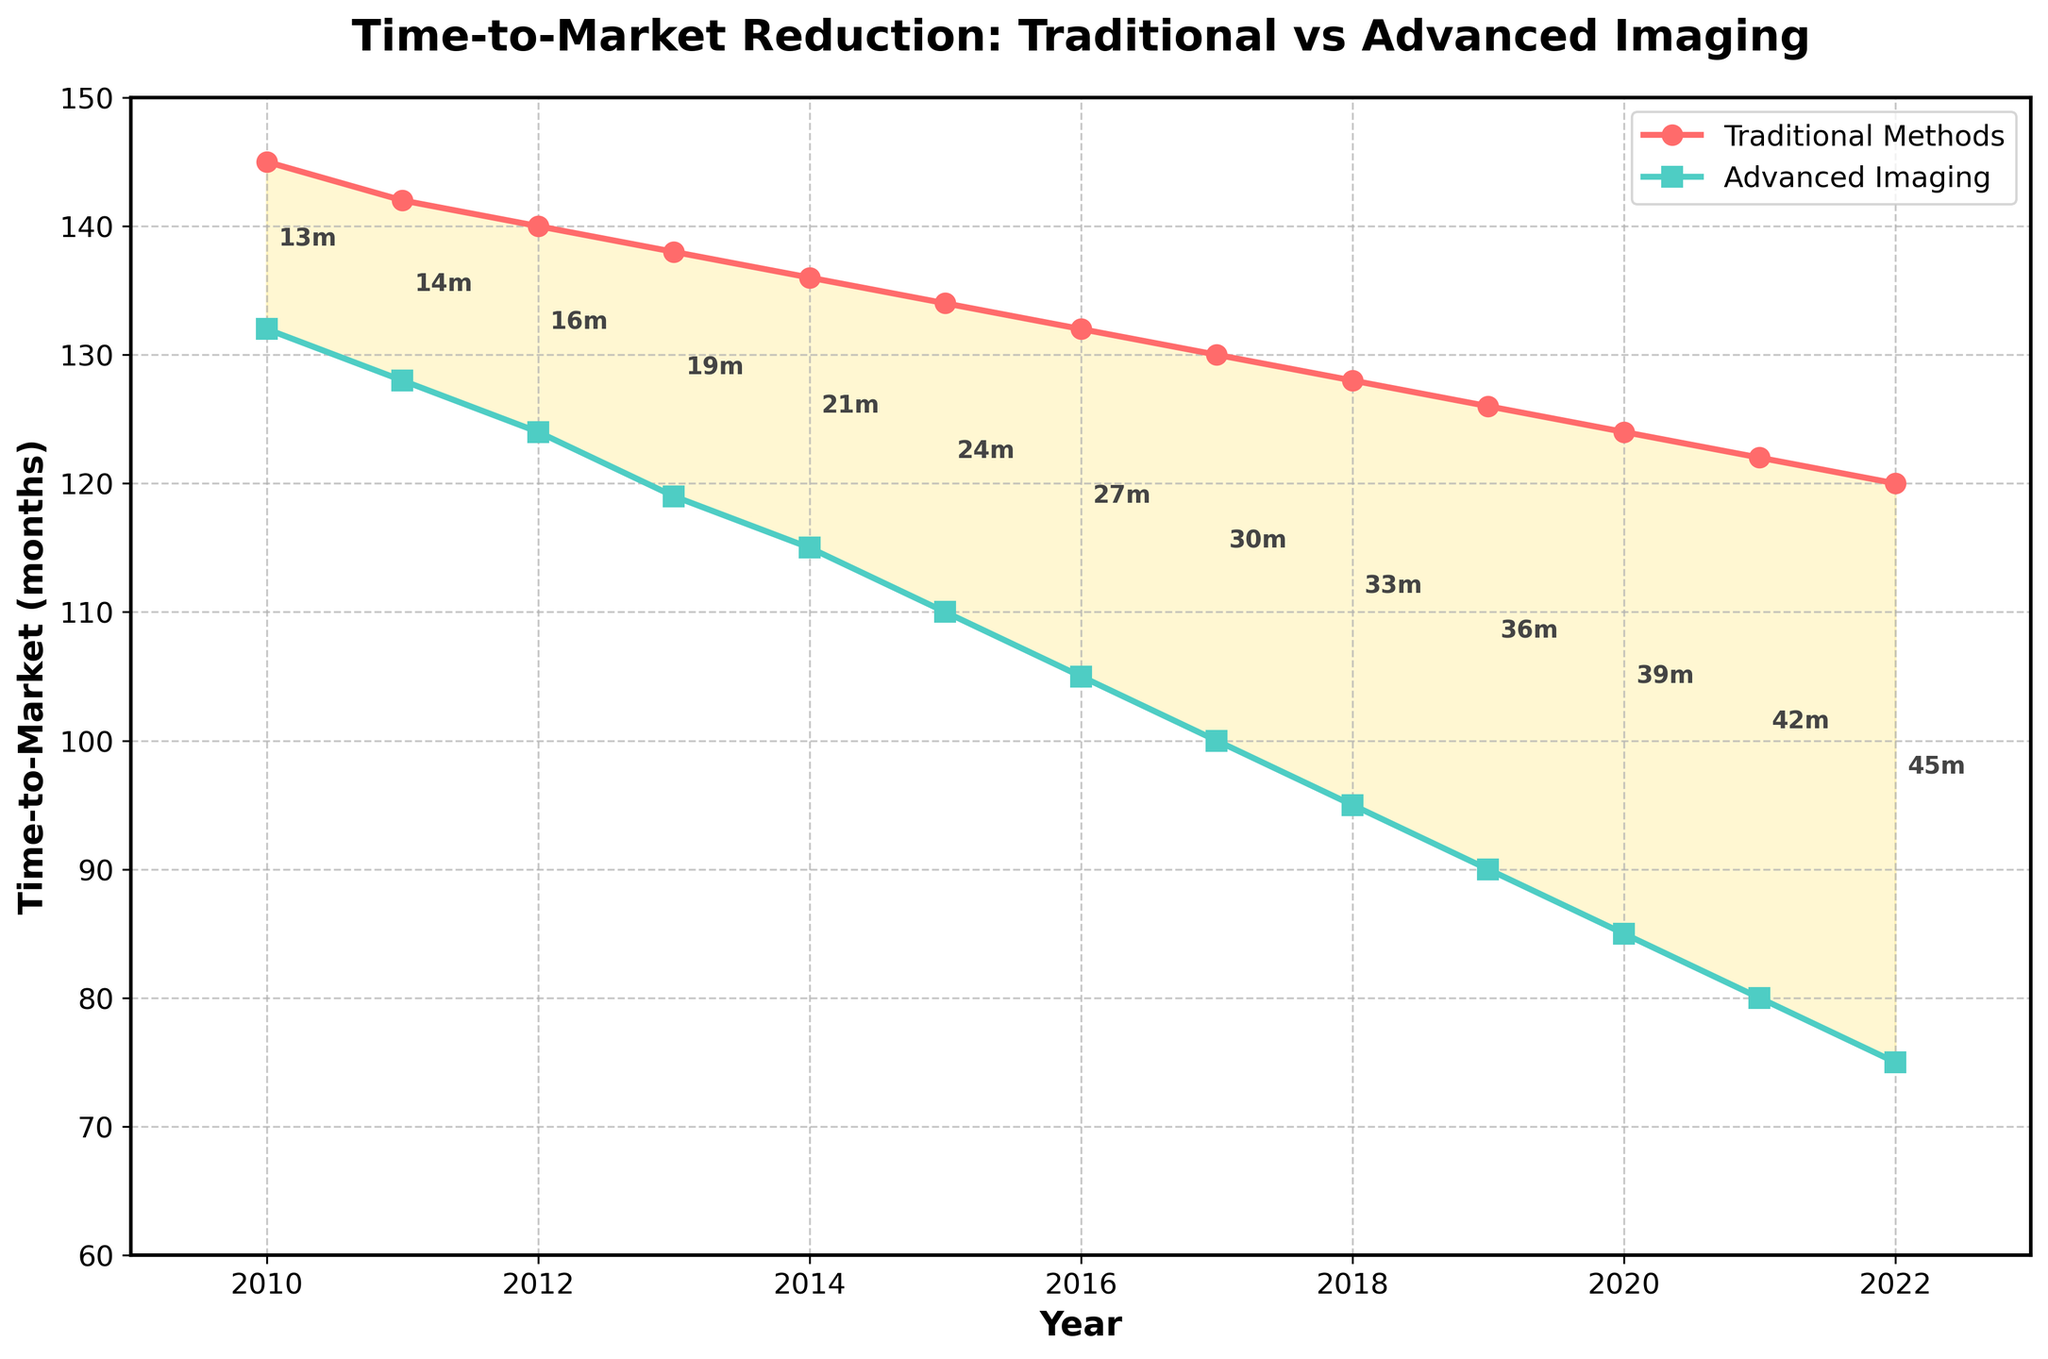What is the reduction in time-to-market for drugs developed using advanced imaging techniques from 2010 to 2022? To find the reduction in time-to-market for advanced imaging, identify the time in 2010 (132 months) and 2022 (75 months). Subtract the 2022 value from the 2010 value: 132 - 75 = 57 months.
Answer: 57 months From which year did the time-to-market for advanced imaging techniques become consistently 50 months or less compared to traditional methods? Find the year when the time difference between traditional methods and advanced imaging techniques consistently became 50 months or less from the annotations. This occurs first in 2017 and every subsequent year: 130 - 100 = 30 months reduction.
Answer: 2017 What is the general trend in time-to-market for both traditional methods and advanced imaging techniques from 2010 to 2022? Both methods show a downward trend in time-to-market over the years. The time for traditional methods decreases from 145 months in 2010 to 120 months in 2022, and advanced imaging decreases from 132 months in 2010 to 75 months in 2022.
Answer: Downward trend By how many months did the time-to-market improve for traditional methods between 2010 and 2022 compared to advanced imaging techniques? Determine the improvement for both methods by subtracting the 2022 values from the 2010 values: Traditional: 145 - 120 = 25 months; Advanced imaging: 132 - 75 = 57 months. The improvement in advanced imaging is 57 months, while traditional methods improve by only 25 months, so advanced imaging improved by 57 - 25 = 32 months more.
Answer: 32 months In which year did the time-to-market for advanced imaging techniques first drop below 100 months? Locate the first year on the graph where the advanced imaging time-to-market is below 100 months. This happens in 2017.
Answer: 2017 What is the average time-to-market for traditional methods between 2010 and 2022? Sum the time-to-market values for traditional methods from 2010 to 2022 and divide by the number of years: (145 + 142 + 140 + 138 + 136 + 134 + 132 + 130 + 128 + 126 + 124 + 122 + 120) / 13 = 132.54 months.
Answer: 132.54 months Which year shows the greatest difference in time-to-market between traditional methods and advanced imaging techniques? Identify the year with the greatest annotated difference on the graph between the two methods. The year with the largest gap of 45 months is 2022.
Answer: 2022 